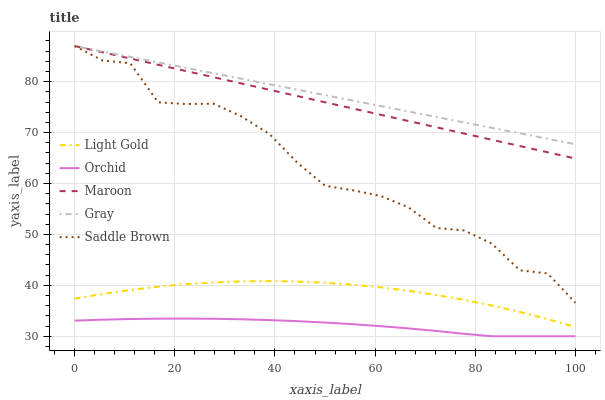Does Orchid have the minimum area under the curve?
Answer yes or no. Yes. Does Gray have the maximum area under the curve?
Answer yes or no. Yes. Does Light Gold have the minimum area under the curve?
Answer yes or no. No. Does Light Gold have the maximum area under the curve?
Answer yes or no. No. Is Gray the smoothest?
Answer yes or no. Yes. Is Saddle Brown the roughest?
Answer yes or no. Yes. Is Light Gold the smoothest?
Answer yes or no. No. Is Light Gold the roughest?
Answer yes or no. No. Does Light Gold have the lowest value?
Answer yes or no. No. Does Maroon have the highest value?
Answer yes or no. Yes. Does Light Gold have the highest value?
Answer yes or no. No. Is Orchid less than Saddle Brown?
Answer yes or no. Yes. Is Gray greater than Light Gold?
Answer yes or no. Yes. Does Orchid intersect Saddle Brown?
Answer yes or no. No. 